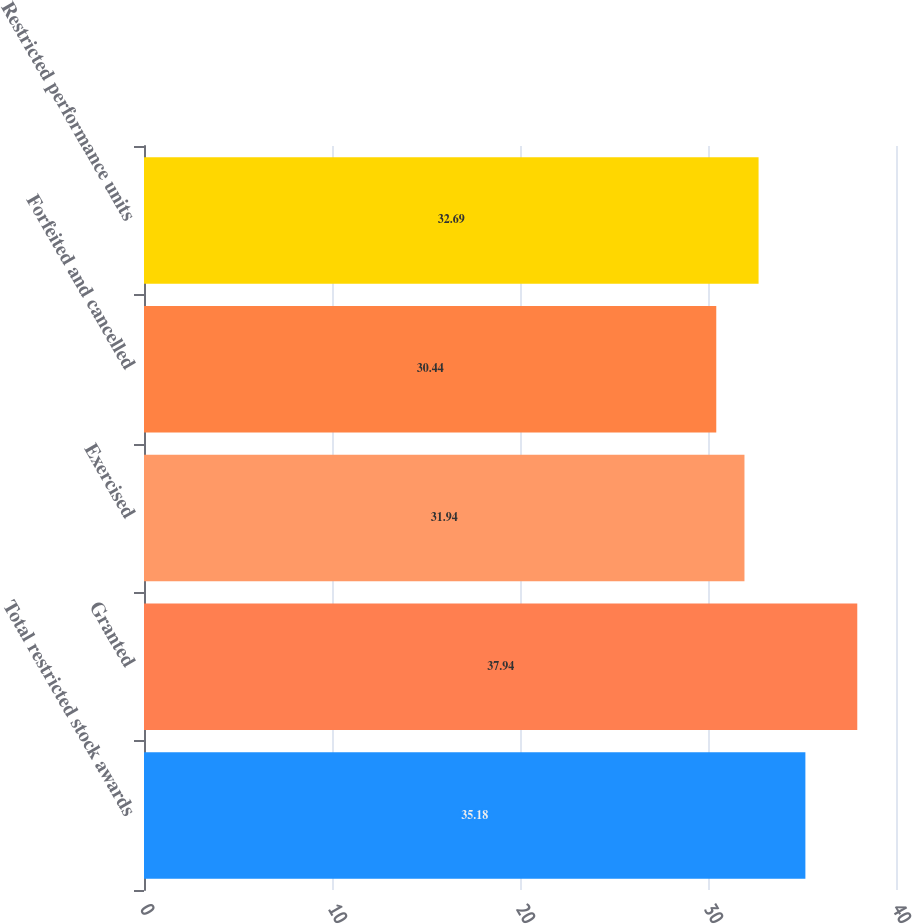Convert chart. <chart><loc_0><loc_0><loc_500><loc_500><bar_chart><fcel>Total restricted stock awards<fcel>Granted<fcel>Exercised<fcel>Forfeited and cancelled<fcel>Restricted performance units<nl><fcel>35.18<fcel>37.94<fcel>31.94<fcel>30.44<fcel>32.69<nl></chart> 